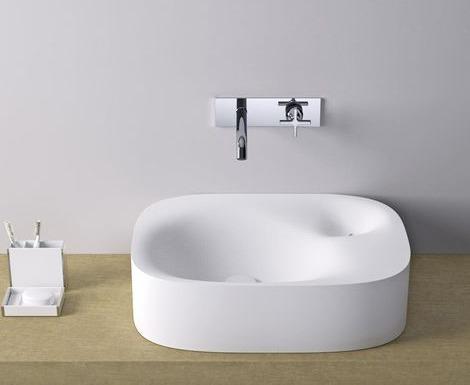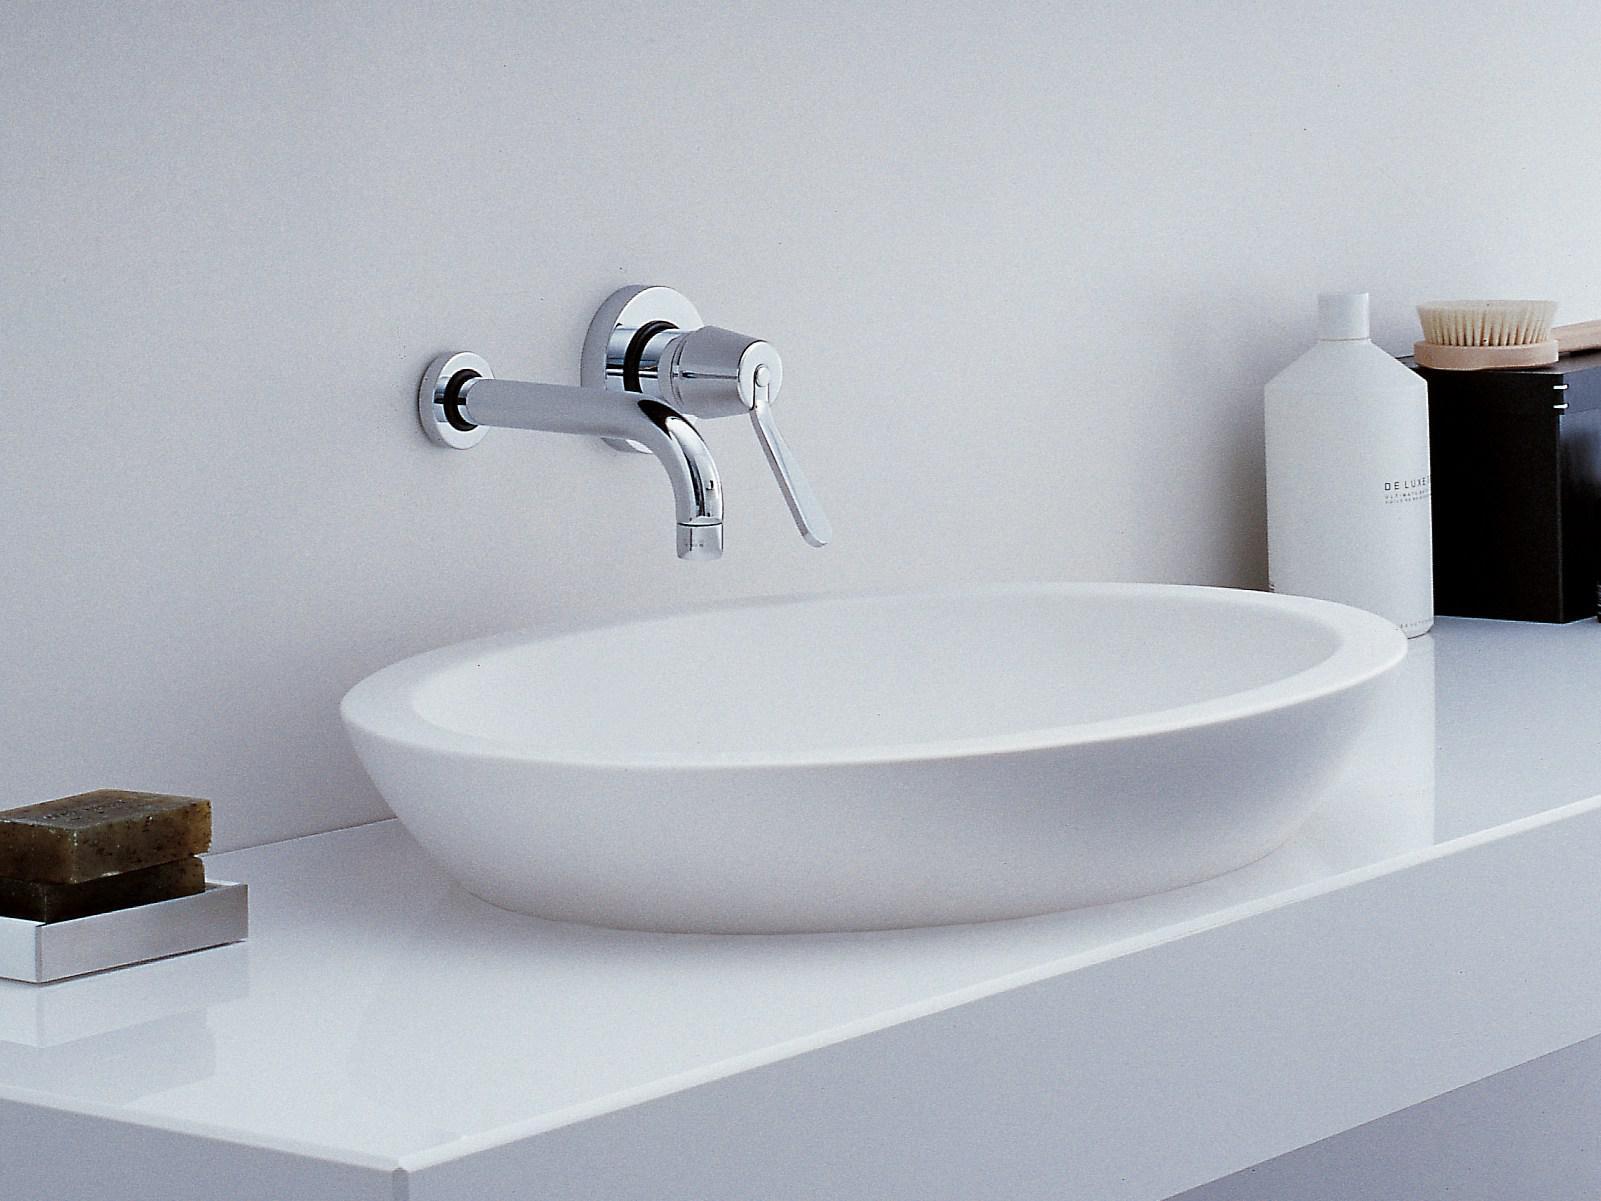The first image is the image on the left, the second image is the image on the right. Evaluate the accuracy of this statement regarding the images: "There are bars of soap on the left side of a wash basin in the right image.". Is it true? Answer yes or no. Yes. The first image is the image on the left, the second image is the image on the right. Evaluate the accuracy of this statement regarding the images: "In one of the images, a bar of soap can be seen next to a sink.". Is it true? Answer yes or no. Yes. 